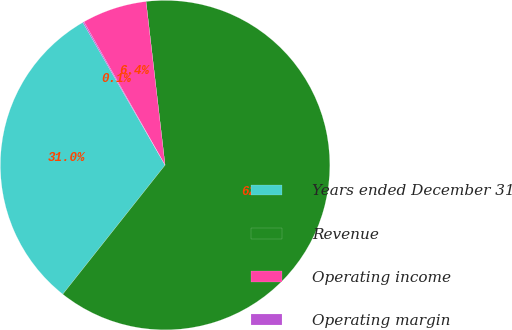<chart> <loc_0><loc_0><loc_500><loc_500><pie_chart><fcel>Years ended December 31<fcel>Revenue<fcel>Operating income<fcel>Operating margin<nl><fcel>31.01%<fcel>62.51%<fcel>6.36%<fcel>0.12%<nl></chart> 